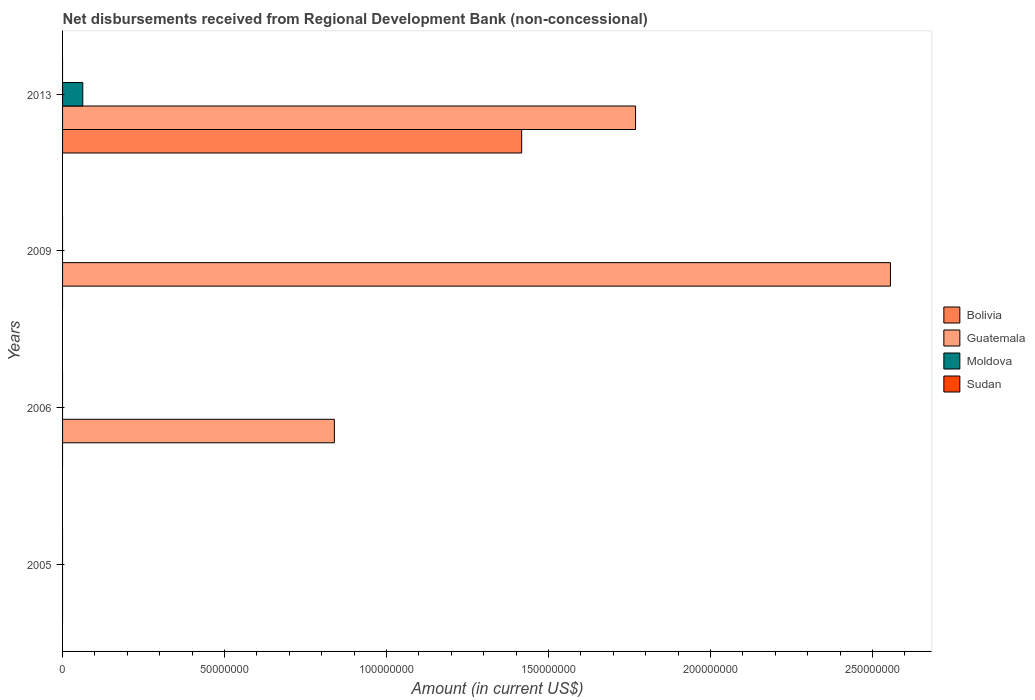Are the number of bars per tick equal to the number of legend labels?
Your answer should be very brief. No. How many bars are there on the 1st tick from the bottom?
Keep it short and to the point. 0. In how many cases, is the number of bars for a given year not equal to the number of legend labels?
Offer a terse response. 4. What is the amount of disbursements received from Regional Development Bank in Moldova in 2006?
Give a very brief answer. 0. Across all years, what is the maximum amount of disbursements received from Regional Development Bank in Guatemala?
Offer a terse response. 2.56e+08. Across all years, what is the minimum amount of disbursements received from Regional Development Bank in Moldova?
Give a very brief answer. 0. What is the total amount of disbursements received from Regional Development Bank in Guatemala in the graph?
Ensure brevity in your answer.  5.16e+08. What is the difference between the amount of disbursements received from Regional Development Bank in Guatemala in 2006 and that in 2013?
Your response must be concise. -9.30e+07. What is the average amount of disbursements received from Regional Development Bank in Moldova per year?
Offer a very short reply. 1.56e+06. In the year 2013, what is the difference between the amount of disbursements received from Regional Development Bank in Guatemala and amount of disbursements received from Regional Development Bank in Bolivia?
Give a very brief answer. 3.52e+07. In how many years, is the amount of disbursements received from Regional Development Bank in Bolivia greater than 190000000 US$?
Ensure brevity in your answer.  0. What is the ratio of the amount of disbursements received from Regional Development Bank in Guatemala in 2006 to that in 2013?
Ensure brevity in your answer.  0.47. What is the difference between the highest and the second highest amount of disbursements received from Regional Development Bank in Guatemala?
Give a very brief answer. 7.87e+07. What is the difference between the highest and the lowest amount of disbursements received from Regional Development Bank in Guatemala?
Your response must be concise. 2.56e+08. Is the sum of the amount of disbursements received from Regional Development Bank in Guatemala in 2006 and 2009 greater than the maximum amount of disbursements received from Regional Development Bank in Moldova across all years?
Ensure brevity in your answer.  Yes. Is it the case that in every year, the sum of the amount of disbursements received from Regional Development Bank in Moldova and amount of disbursements received from Regional Development Bank in Sudan is greater than the amount of disbursements received from Regional Development Bank in Guatemala?
Your answer should be very brief. No. How many years are there in the graph?
Ensure brevity in your answer.  4. Does the graph contain any zero values?
Your answer should be very brief. Yes. How many legend labels are there?
Your answer should be compact. 4. What is the title of the graph?
Keep it short and to the point. Net disbursements received from Regional Development Bank (non-concessional). What is the Amount (in current US$) in Bolivia in 2005?
Provide a succinct answer. 0. What is the Amount (in current US$) of Moldova in 2005?
Give a very brief answer. 0. What is the Amount (in current US$) of Sudan in 2005?
Your answer should be very brief. 0. What is the Amount (in current US$) of Bolivia in 2006?
Offer a very short reply. 0. What is the Amount (in current US$) in Guatemala in 2006?
Make the answer very short. 8.39e+07. What is the Amount (in current US$) in Guatemala in 2009?
Make the answer very short. 2.56e+08. What is the Amount (in current US$) of Moldova in 2009?
Your response must be concise. 0. What is the Amount (in current US$) of Bolivia in 2013?
Your answer should be compact. 1.42e+08. What is the Amount (in current US$) of Guatemala in 2013?
Your answer should be very brief. 1.77e+08. What is the Amount (in current US$) of Moldova in 2013?
Give a very brief answer. 6.24e+06. What is the Amount (in current US$) of Sudan in 2013?
Give a very brief answer. 0. Across all years, what is the maximum Amount (in current US$) of Bolivia?
Offer a terse response. 1.42e+08. Across all years, what is the maximum Amount (in current US$) in Guatemala?
Keep it short and to the point. 2.56e+08. Across all years, what is the maximum Amount (in current US$) of Moldova?
Your response must be concise. 6.24e+06. Across all years, what is the minimum Amount (in current US$) of Moldova?
Provide a succinct answer. 0. What is the total Amount (in current US$) of Bolivia in the graph?
Provide a succinct answer. 1.42e+08. What is the total Amount (in current US$) of Guatemala in the graph?
Keep it short and to the point. 5.16e+08. What is the total Amount (in current US$) of Moldova in the graph?
Your answer should be very brief. 6.24e+06. What is the total Amount (in current US$) of Sudan in the graph?
Make the answer very short. 0. What is the difference between the Amount (in current US$) in Guatemala in 2006 and that in 2009?
Provide a succinct answer. -1.72e+08. What is the difference between the Amount (in current US$) in Guatemala in 2006 and that in 2013?
Make the answer very short. -9.30e+07. What is the difference between the Amount (in current US$) in Guatemala in 2009 and that in 2013?
Ensure brevity in your answer.  7.87e+07. What is the difference between the Amount (in current US$) in Guatemala in 2006 and the Amount (in current US$) in Moldova in 2013?
Keep it short and to the point. 7.77e+07. What is the difference between the Amount (in current US$) of Guatemala in 2009 and the Amount (in current US$) of Moldova in 2013?
Make the answer very short. 2.49e+08. What is the average Amount (in current US$) in Bolivia per year?
Give a very brief answer. 3.54e+07. What is the average Amount (in current US$) in Guatemala per year?
Ensure brevity in your answer.  1.29e+08. What is the average Amount (in current US$) in Moldova per year?
Provide a short and direct response. 1.56e+06. What is the average Amount (in current US$) of Sudan per year?
Your answer should be very brief. 0. In the year 2013, what is the difference between the Amount (in current US$) in Bolivia and Amount (in current US$) in Guatemala?
Make the answer very short. -3.52e+07. In the year 2013, what is the difference between the Amount (in current US$) in Bolivia and Amount (in current US$) in Moldova?
Offer a terse response. 1.35e+08. In the year 2013, what is the difference between the Amount (in current US$) in Guatemala and Amount (in current US$) in Moldova?
Make the answer very short. 1.71e+08. What is the ratio of the Amount (in current US$) in Guatemala in 2006 to that in 2009?
Your answer should be compact. 0.33. What is the ratio of the Amount (in current US$) of Guatemala in 2006 to that in 2013?
Provide a short and direct response. 0.47. What is the ratio of the Amount (in current US$) in Guatemala in 2009 to that in 2013?
Make the answer very short. 1.44. What is the difference between the highest and the second highest Amount (in current US$) in Guatemala?
Provide a short and direct response. 7.87e+07. What is the difference between the highest and the lowest Amount (in current US$) in Bolivia?
Your response must be concise. 1.42e+08. What is the difference between the highest and the lowest Amount (in current US$) of Guatemala?
Provide a short and direct response. 2.56e+08. What is the difference between the highest and the lowest Amount (in current US$) in Moldova?
Ensure brevity in your answer.  6.24e+06. 